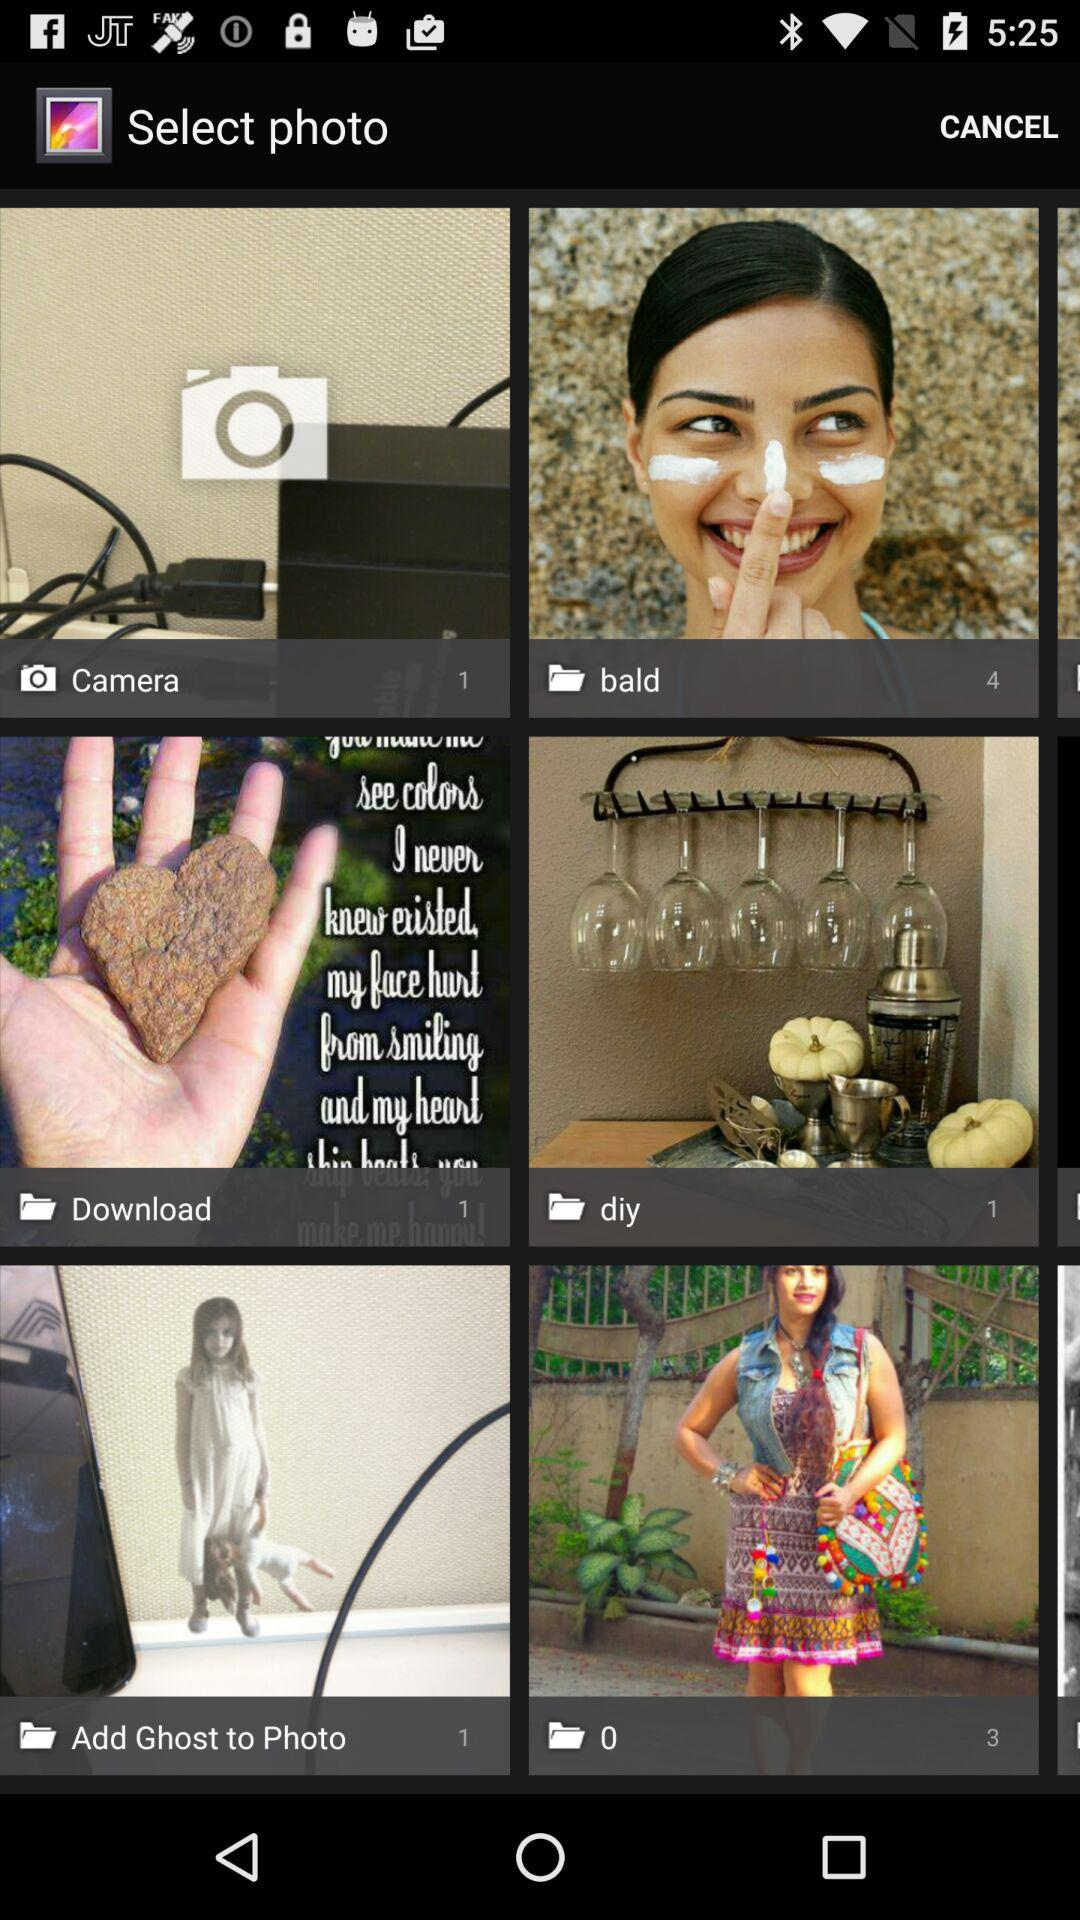How many pictures are in the "Download" folder? There is 1 picture in the "Download" folder. 